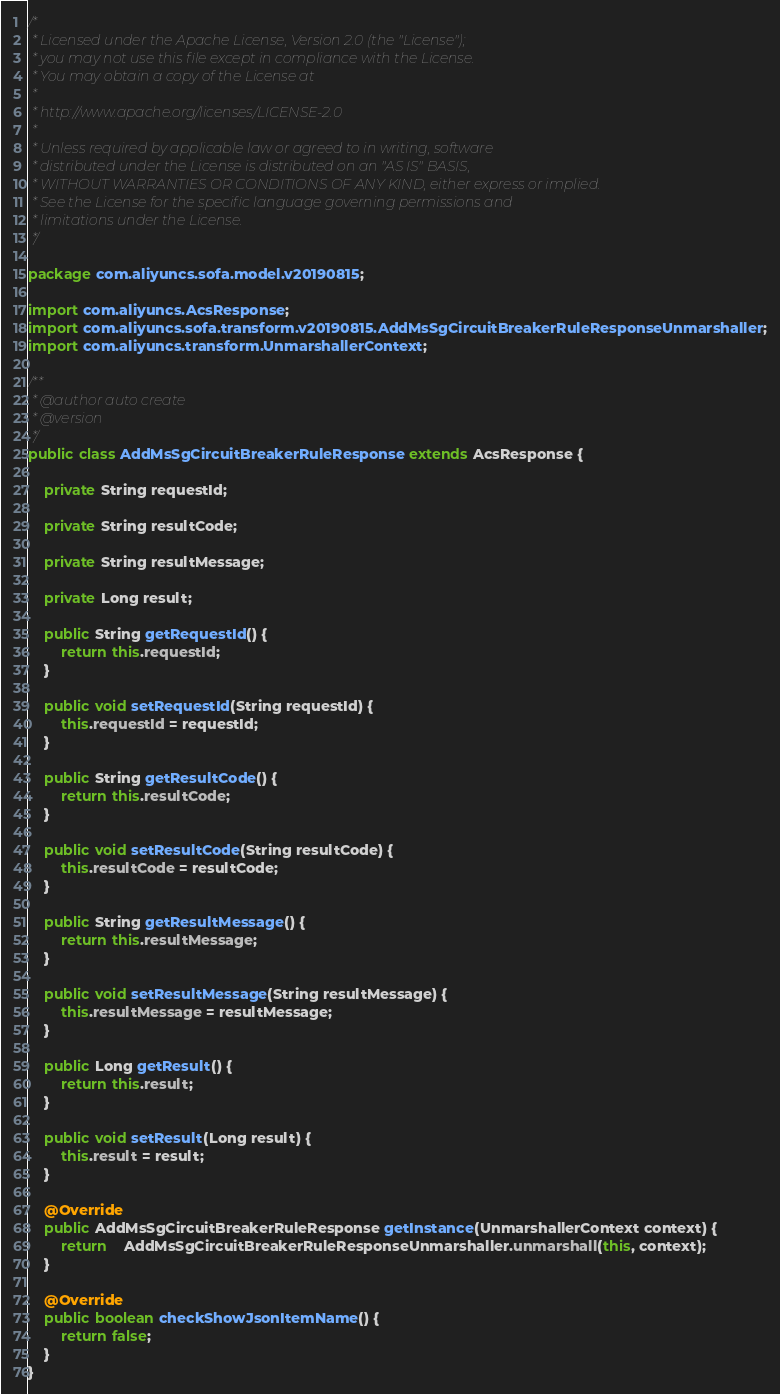Convert code to text. <code><loc_0><loc_0><loc_500><loc_500><_Java_>/*
 * Licensed under the Apache License, Version 2.0 (the "License");
 * you may not use this file except in compliance with the License.
 * You may obtain a copy of the License at
 *
 * http://www.apache.org/licenses/LICENSE-2.0
 *
 * Unless required by applicable law or agreed to in writing, software
 * distributed under the License is distributed on an "AS IS" BASIS,
 * WITHOUT WARRANTIES OR CONDITIONS OF ANY KIND, either express or implied.
 * See the License for the specific language governing permissions and
 * limitations under the License.
 */

package com.aliyuncs.sofa.model.v20190815;

import com.aliyuncs.AcsResponse;
import com.aliyuncs.sofa.transform.v20190815.AddMsSgCircuitBreakerRuleResponseUnmarshaller;
import com.aliyuncs.transform.UnmarshallerContext;

/**
 * @author auto create
 * @version 
 */
public class AddMsSgCircuitBreakerRuleResponse extends AcsResponse {

	private String requestId;

	private String resultCode;

	private String resultMessage;

	private Long result;

	public String getRequestId() {
		return this.requestId;
	}

	public void setRequestId(String requestId) {
		this.requestId = requestId;
	}

	public String getResultCode() {
		return this.resultCode;
	}

	public void setResultCode(String resultCode) {
		this.resultCode = resultCode;
	}

	public String getResultMessage() {
		return this.resultMessage;
	}

	public void setResultMessage(String resultMessage) {
		this.resultMessage = resultMessage;
	}

	public Long getResult() {
		return this.result;
	}

	public void setResult(Long result) {
		this.result = result;
	}

	@Override
	public AddMsSgCircuitBreakerRuleResponse getInstance(UnmarshallerContext context) {
		return	AddMsSgCircuitBreakerRuleResponseUnmarshaller.unmarshall(this, context);
	}

	@Override
	public boolean checkShowJsonItemName() {
		return false;
	}
}
</code> 